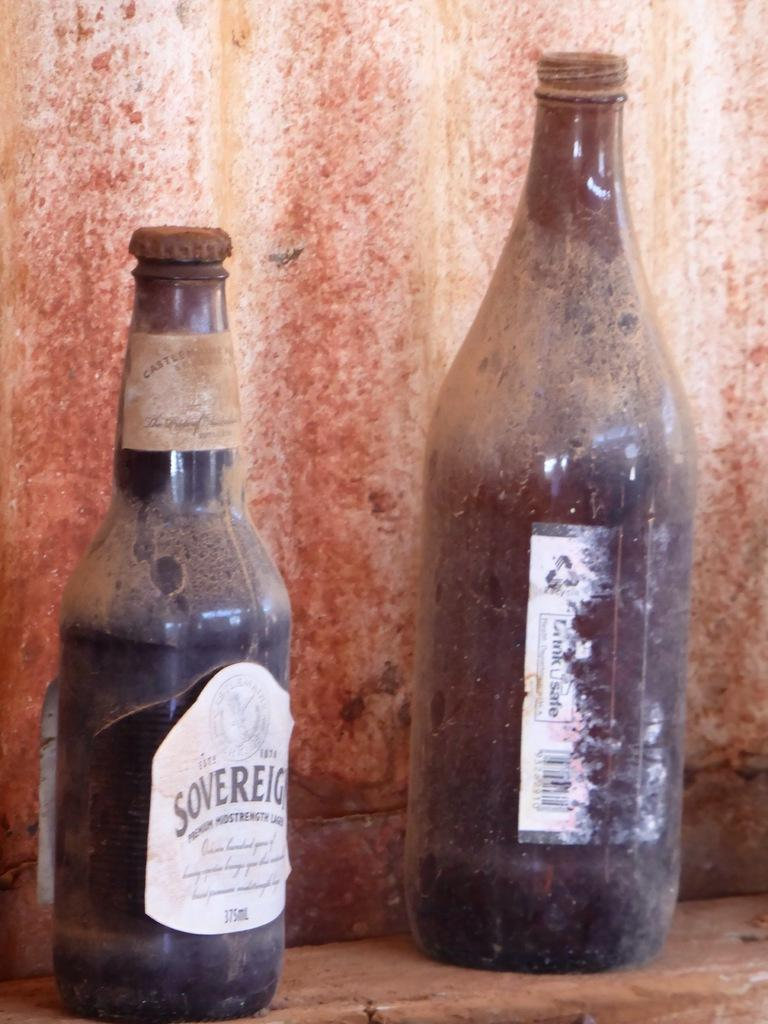<image>
Describe the image concisely. An old dirty bottle of Sovereign sits next to a larger bottle that is also dirty. 